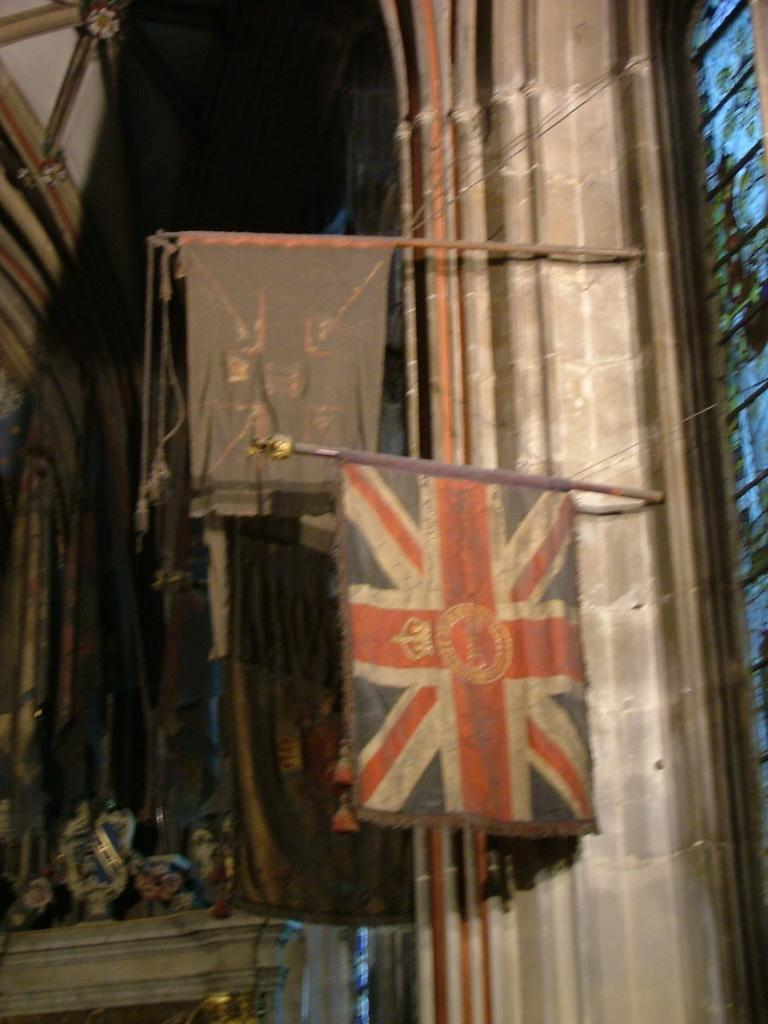What can be seen in the image that represents a symbol or country? There are flags in the image. What material are the objects in the image made of? The objects in the image are made of metal, as there are metal rods present. What type of decorative glass can be seen in the image? There is a stained glass in the image. What type of poison is being used to clean the stained glass in the image? There is no poison present in the image, and the stained glass being used to walk on the road in the image? 